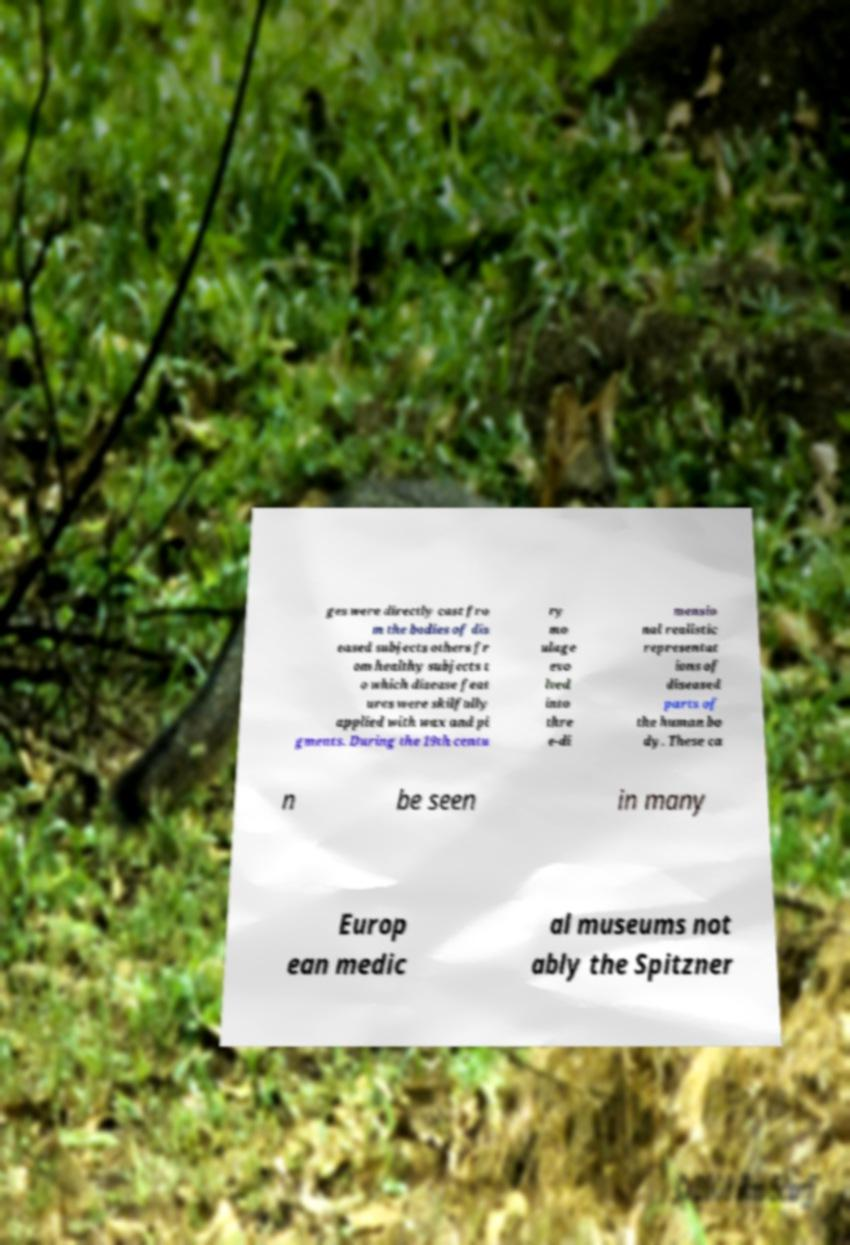There's text embedded in this image that I need extracted. Can you transcribe it verbatim? ges were directly cast fro m the bodies of dis eased subjects others fr om healthy subjects t o which disease feat ures were skilfully applied with wax and pi gments. During the 19th centu ry mo ulage evo lved into thre e-di mensio nal realistic representat ions of diseased parts of the human bo dy. These ca n be seen in many Europ ean medic al museums not ably the Spitzner 